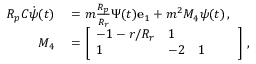Convert formula to latex. <formula><loc_0><loc_0><loc_500><loc_500>\begin{array} { r l } { R _ { p } C \dot { \psi } ( t ) } & = m \frac { R _ { p } } { R _ { r } } \Psi ( t ) e _ { 1 } + m ^ { 2 } M _ { 4 } \psi ( t ) \, , } \\ { M _ { 4 } } & = \left [ \begin{array} { l l l l l } { - 1 - r / R _ { r } } & { 1 } \\ { 1 } & { - 2 } & { 1 } \end{array} \right ] \, , } \end{array}</formula> 